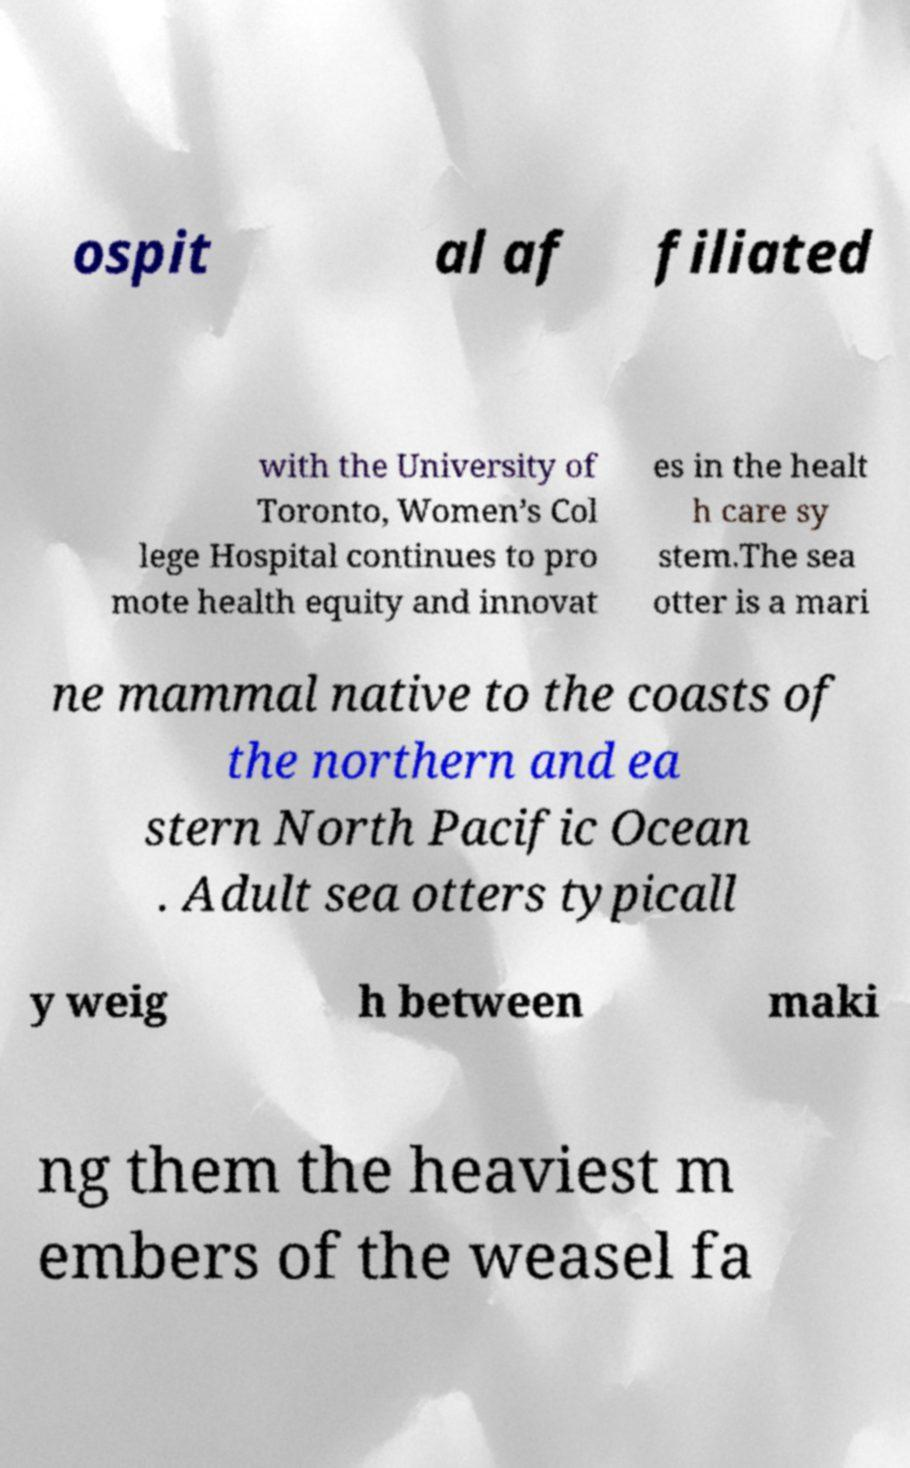Could you assist in decoding the text presented in this image and type it out clearly? ospit al af filiated with the University of Toronto, Women’s Col lege Hospital continues to pro mote health equity and innovat es in the healt h care sy stem.The sea otter is a mari ne mammal native to the coasts of the northern and ea stern North Pacific Ocean . Adult sea otters typicall y weig h between maki ng them the heaviest m embers of the weasel fa 